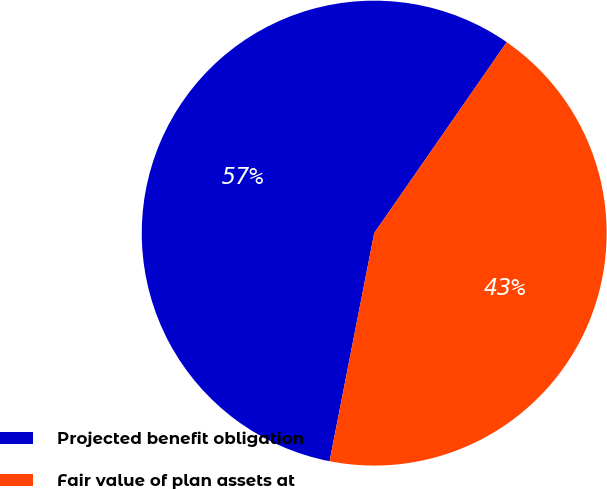Convert chart to OTSL. <chart><loc_0><loc_0><loc_500><loc_500><pie_chart><fcel>Projected benefit obligation<fcel>Fair value of plan assets at<nl><fcel>56.58%<fcel>43.42%<nl></chart> 